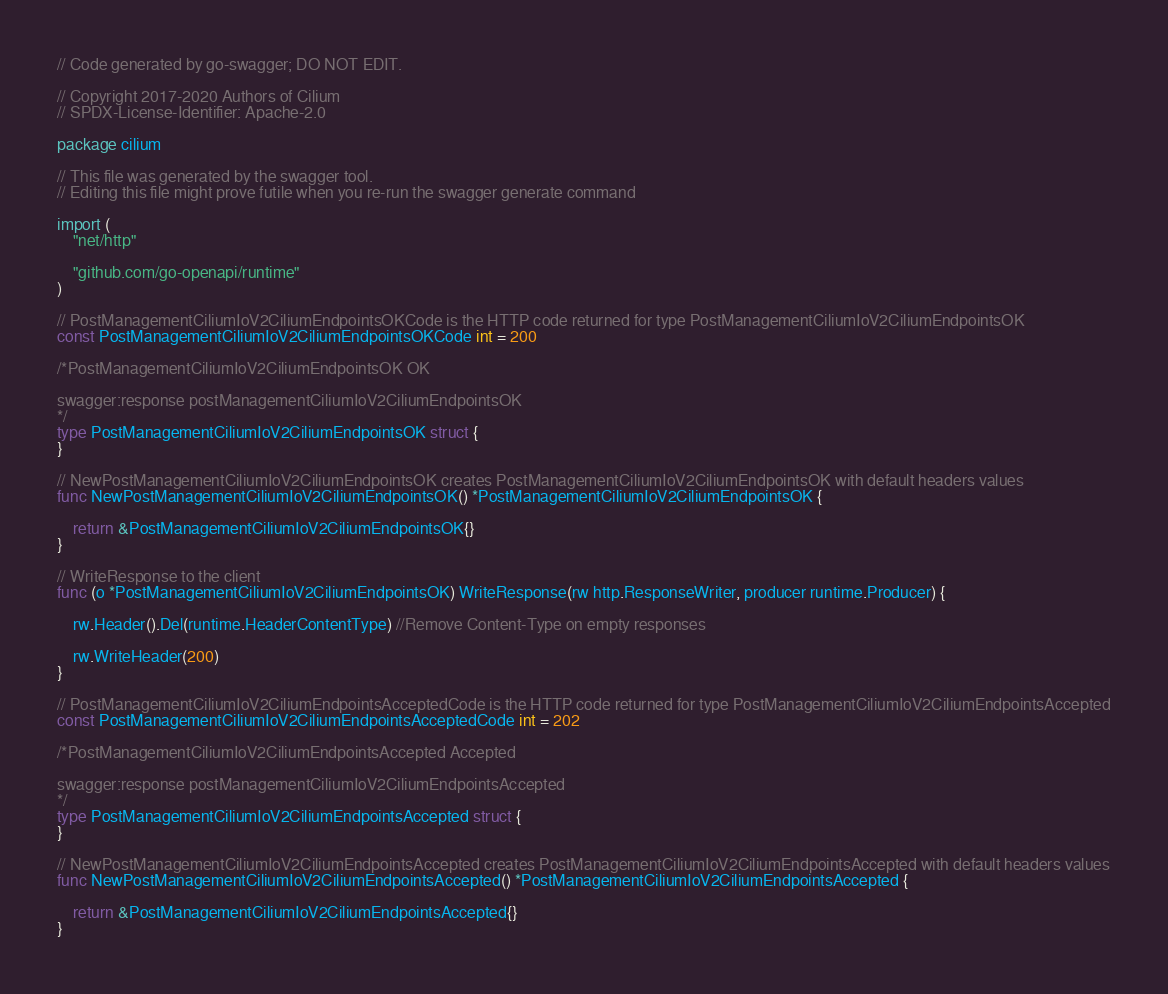Convert code to text. <code><loc_0><loc_0><loc_500><loc_500><_Go_>// Code generated by go-swagger; DO NOT EDIT.

// Copyright 2017-2020 Authors of Cilium
// SPDX-License-Identifier: Apache-2.0

package cilium

// This file was generated by the swagger tool.
// Editing this file might prove futile when you re-run the swagger generate command

import (
	"net/http"

	"github.com/go-openapi/runtime"
)

// PostManagementCiliumIoV2CiliumEndpointsOKCode is the HTTP code returned for type PostManagementCiliumIoV2CiliumEndpointsOK
const PostManagementCiliumIoV2CiliumEndpointsOKCode int = 200

/*PostManagementCiliumIoV2CiliumEndpointsOK OK

swagger:response postManagementCiliumIoV2CiliumEndpointsOK
*/
type PostManagementCiliumIoV2CiliumEndpointsOK struct {
}

// NewPostManagementCiliumIoV2CiliumEndpointsOK creates PostManagementCiliumIoV2CiliumEndpointsOK with default headers values
func NewPostManagementCiliumIoV2CiliumEndpointsOK() *PostManagementCiliumIoV2CiliumEndpointsOK {

	return &PostManagementCiliumIoV2CiliumEndpointsOK{}
}

// WriteResponse to the client
func (o *PostManagementCiliumIoV2CiliumEndpointsOK) WriteResponse(rw http.ResponseWriter, producer runtime.Producer) {

	rw.Header().Del(runtime.HeaderContentType) //Remove Content-Type on empty responses

	rw.WriteHeader(200)
}

// PostManagementCiliumIoV2CiliumEndpointsAcceptedCode is the HTTP code returned for type PostManagementCiliumIoV2CiliumEndpointsAccepted
const PostManagementCiliumIoV2CiliumEndpointsAcceptedCode int = 202

/*PostManagementCiliumIoV2CiliumEndpointsAccepted Accepted

swagger:response postManagementCiliumIoV2CiliumEndpointsAccepted
*/
type PostManagementCiliumIoV2CiliumEndpointsAccepted struct {
}

// NewPostManagementCiliumIoV2CiliumEndpointsAccepted creates PostManagementCiliumIoV2CiliumEndpointsAccepted with default headers values
func NewPostManagementCiliumIoV2CiliumEndpointsAccepted() *PostManagementCiliumIoV2CiliumEndpointsAccepted {

	return &PostManagementCiliumIoV2CiliumEndpointsAccepted{}
}
</code> 